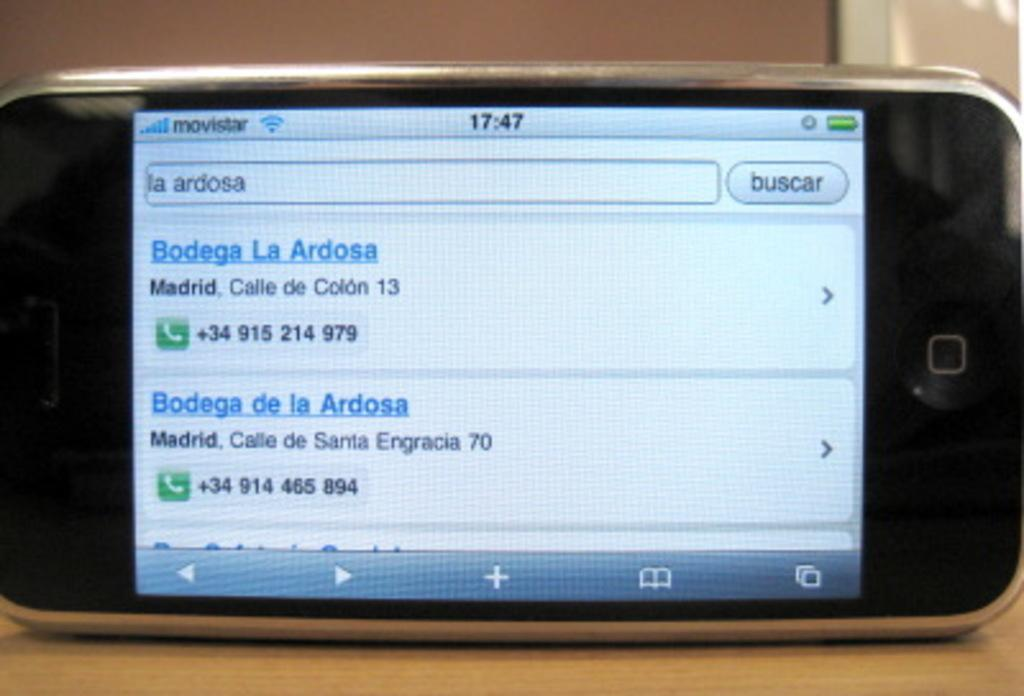<image>
Render a clear and concise summary of the photo. A phone screen that is showing an internet browser that has numbers of a bodega pulled up. 